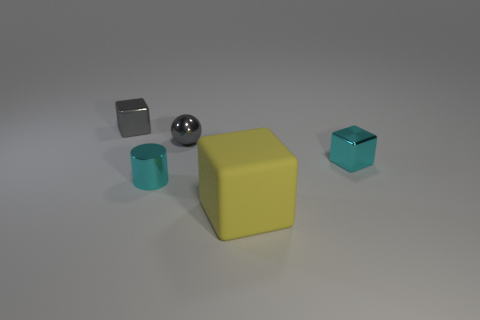Do the ball and the small metal cylinder have the same color? no 